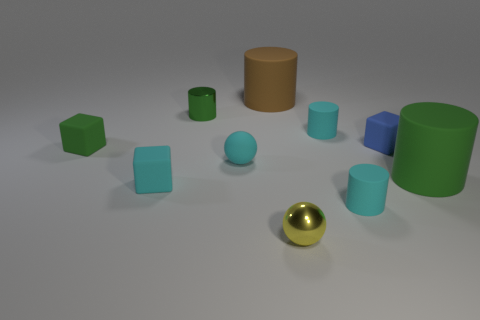What number of other objects are there of the same material as the tiny blue block?
Your answer should be compact. 7. Is the number of tiny cyan spheres behind the small green matte thing greater than the number of tiny yellow metal things that are in front of the yellow shiny sphere?
Make the answer very short. No. Are there any small yellow things?
Your response must be concise. Yes. There is a cube that is the same color as the tiny matte sphere; what is its material?
Keep it short and to the point. Rubber. How many objects are tiny blue blocks or tiny matte blocks?
Ensure brevity in your answer.  3. Are there any large objects that have the same color as the tiny matte sphere?
Provide a short and direct response. No. What number of tiny green shiny objects are behind the tiny blue block that is right of the rubber sphere?
Your answer should be very brief. 1. Are there more cubes than large red metal objects?
Offer a terse response. Yes. Is the material of the brown cylinder the same as the small cyan sphere?
Offer a terse response. Yes. Are there an equal number of rubber cylinders in front of the big green rubber cylinder and big red cylinders?
Keep it short and to the point. No. 